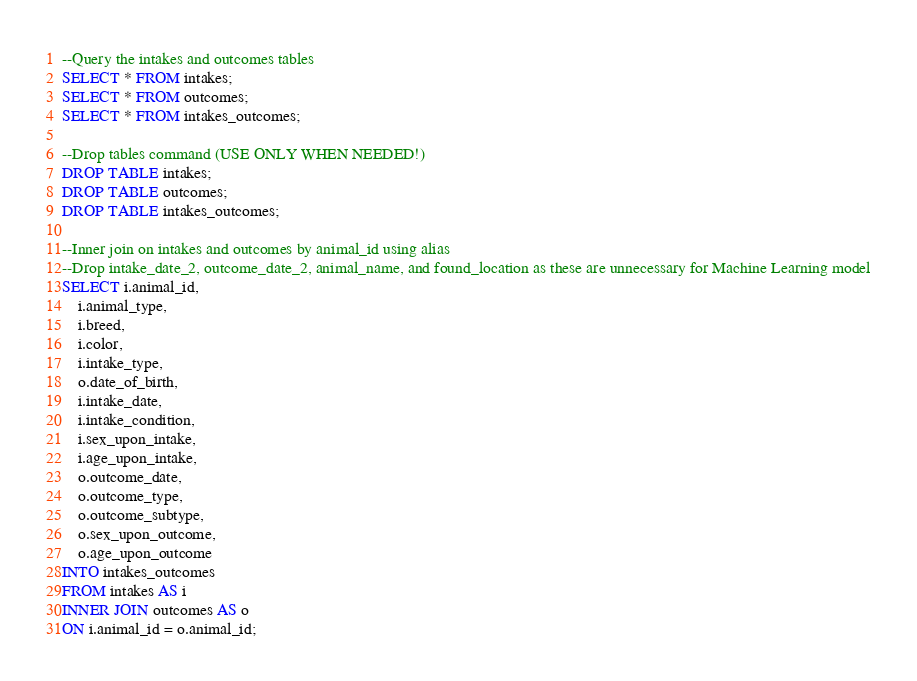<code> <loc_0><loc_0><loc_500><loc_500><_SQL_>--Query the intakes and outcomes tables
SELECT * FROM intakes;
SELECT * FROM outcomes;
SELECT * FROM intakes_outcomes;

--Drop tables command (USE ONLY WHEN NEEDED!)
DROP TABLE intakes;
DROP TABLE outcomes;
DROP TABLE intakes_outcomes;

--Inner join on intakes and outcomes by animal_id using alias
--Drop intake_date_2, outcome_date_2, animal_name, and found_location as these are unnecessary for Machine Learning model
SELECT i.animal_id,
	i.animal_type,
	i.breed,
	i.color,
	i.intake_type,
	o.date_of_birth,
	i.intake_date,
	i.intake_condition,
	i.sex_upon_intake,
	i.age_upon_intake,
	o.outcome_date,
	o.outcome_type,
	o.outcome_subtype,
	o.sex_upon_outcome,
	o.age_upon_outcome
INTO intakes_outcomes
FROM intakes AS i
INNER JOIN outcomes AS o
ON i.animal_id = o.animal_id;</code> 